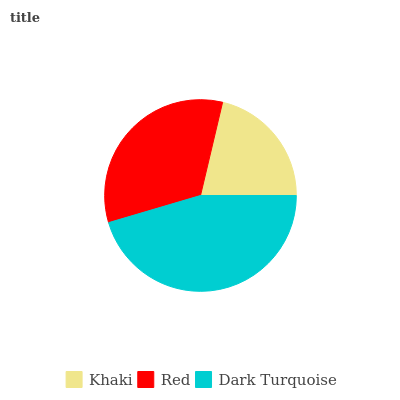Is Khaki the minimum?
Answer yes or no. Yes. Is Dark Turquoise the maximum?
Answer yes or no. Yes. Is Red the minimum?
Answer yes or no. No. Is Red the maximum?
Answer yes or no. No. Is Red greater than Khaki?
Answer yes or no. Yes. Is Khaki less than Red?
Answer yes or no. Yes. Is Khaki greater than Red?
Answer yes or no. No. Is Red less than Khaki?
Answer yes or no. No. Is Red the high median?
Answer yes or no. Yes. Is Red the low median?
Answer yes or no. Yes. Is Khaki the high median?
Answer yes or no. No. Is Khaki the low median?
Answer yes or no. No. 